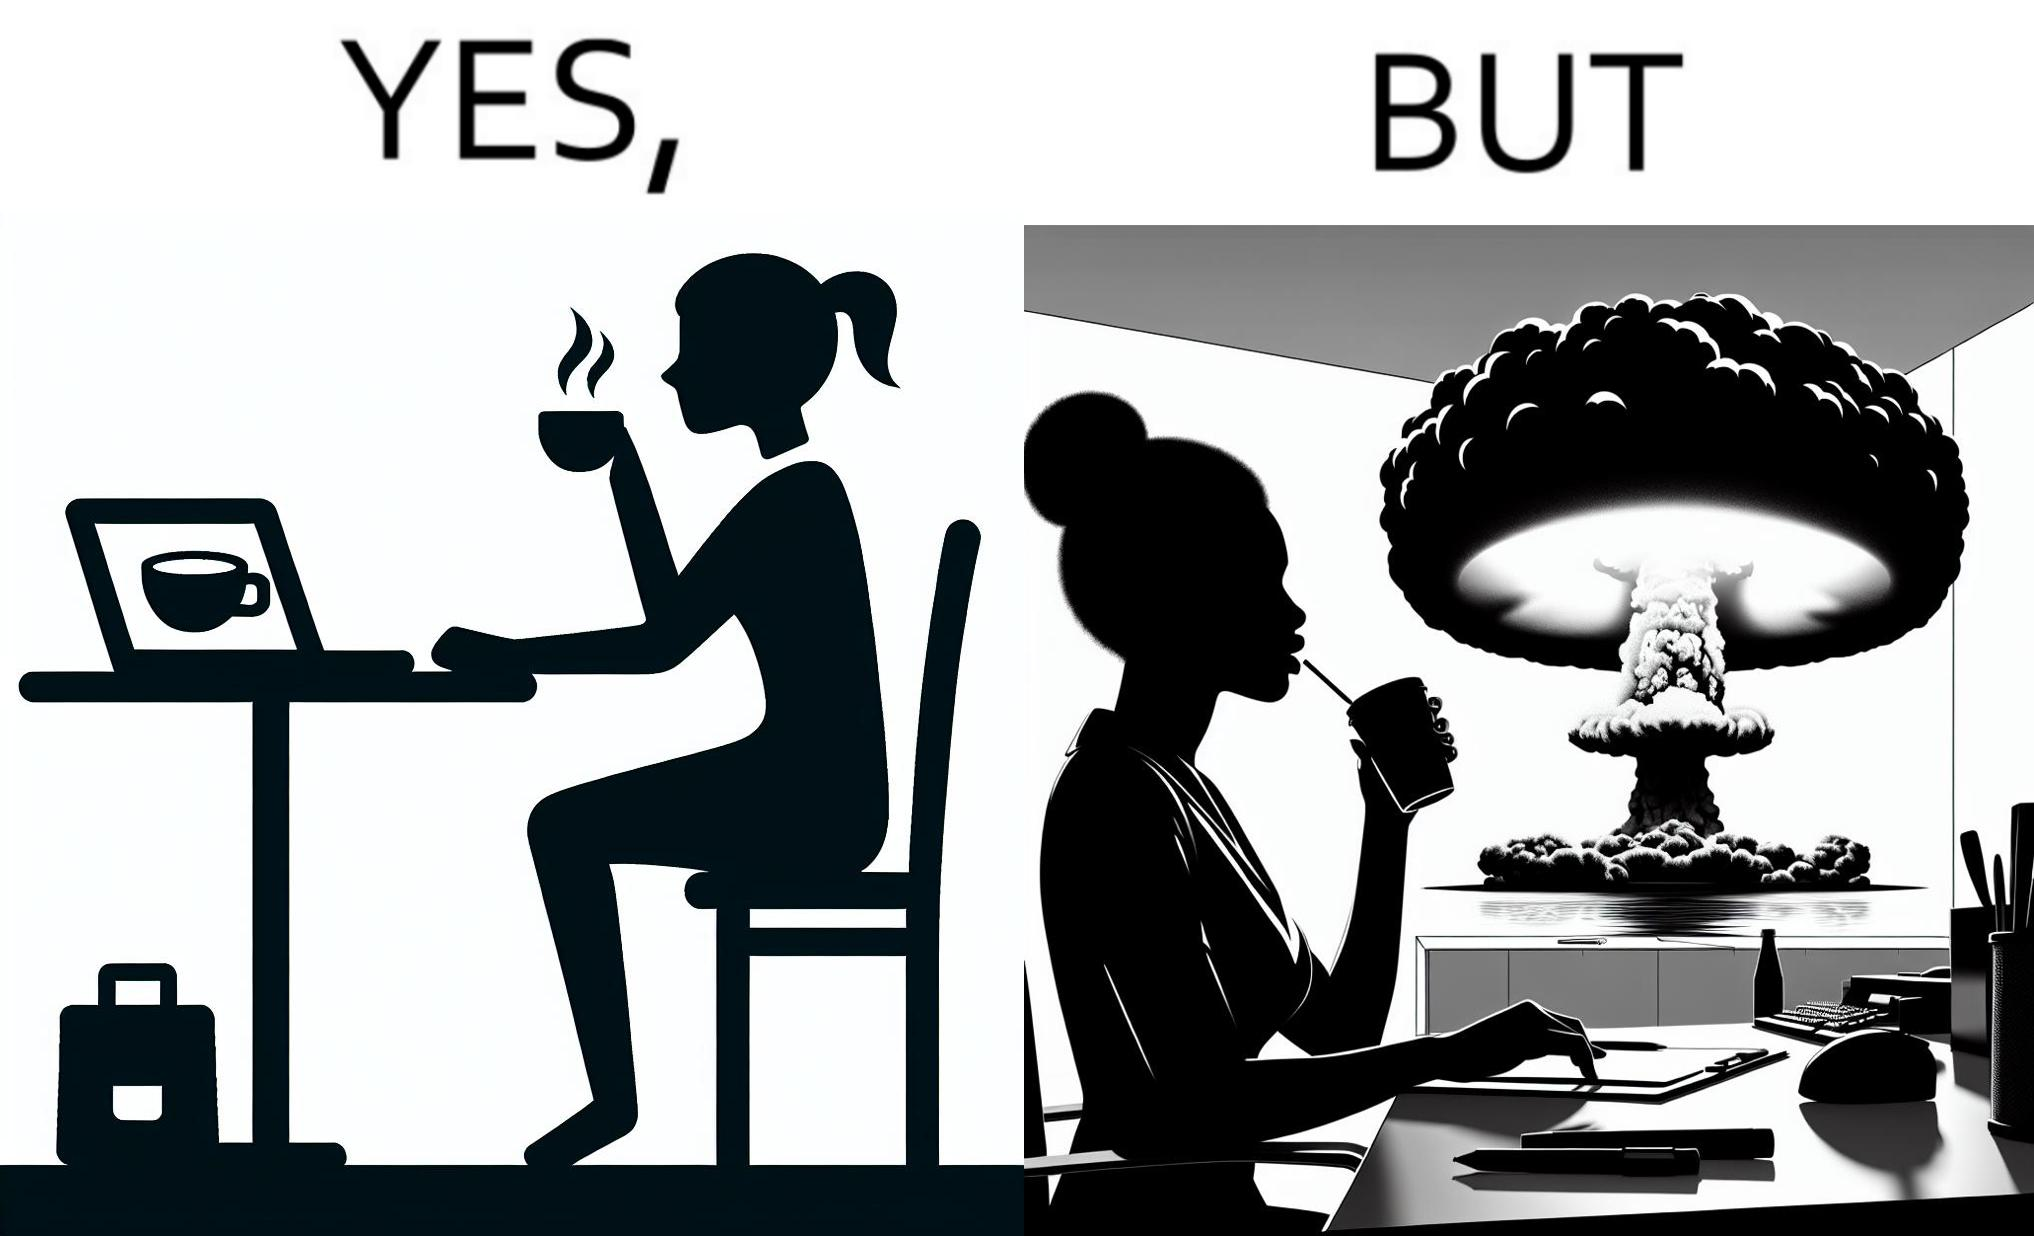Describe the content of this image. The images are funny since it shows a woman simply sipping from a cup at ease in a cafe with her laptop not caring about anything going on outside the cafe even though the situation is very grave,that is, a nuclear blast 